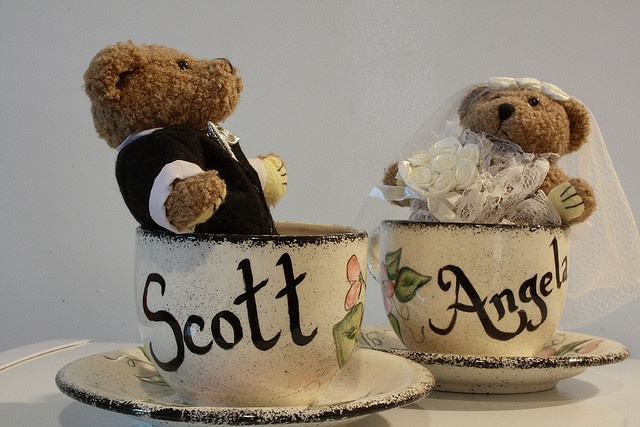Describe the objects in this image and their specific colors. I can see bowl in darkgray, tan, black, and gray tones, teddy bear in darkgray, black, maroon, and gray tones, cup in darkgray, tan, black, and olive tones, teddy bear in darkgray, tan, gray, and maroon tones, and tie in darkgray, black, gray, and tan tones in this image. 